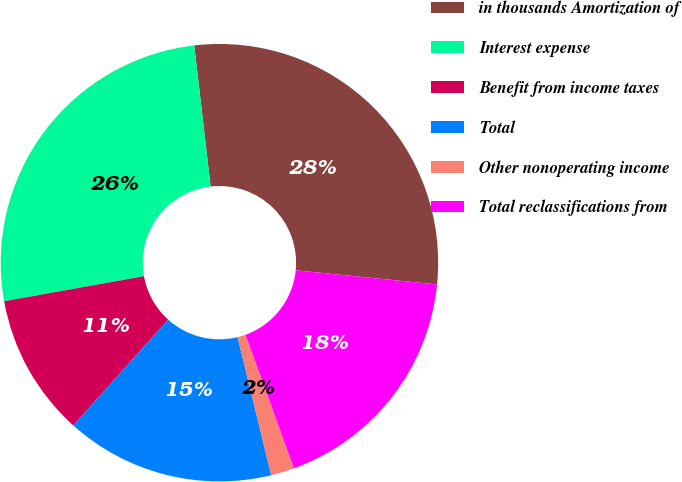<chart> <loc_0><loc_0><loc_500><loc_500><pie_chart><fcel>in thousands Amortization of<fcel>Interest expense<fcel>Benefit from income taxes<fcel>Total<fcel>Other nonoperating income<fcel>Total reclassifications from<nl><fcel>28.42%<fcel>25.98%<fcel>10.53%<fcel>15.45%<fcel>1.73%<fcel>17.88%<nl></chart> 